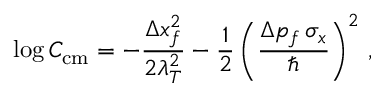Convert formula to latex. <formula><loc_0><loc_0><loc_500><loc_500>\log C _ { c m } = - \frac { \Delta x _ { f } ^ { 2 } } { 2 \lambda _ { T } ^ { 2 } } - \frac { 1 } { 2 } \left ( \frac { \Delta p _ { f } \, \sigma _ { x } } { } \right ) ^ { 2 } \, ,</formula> 